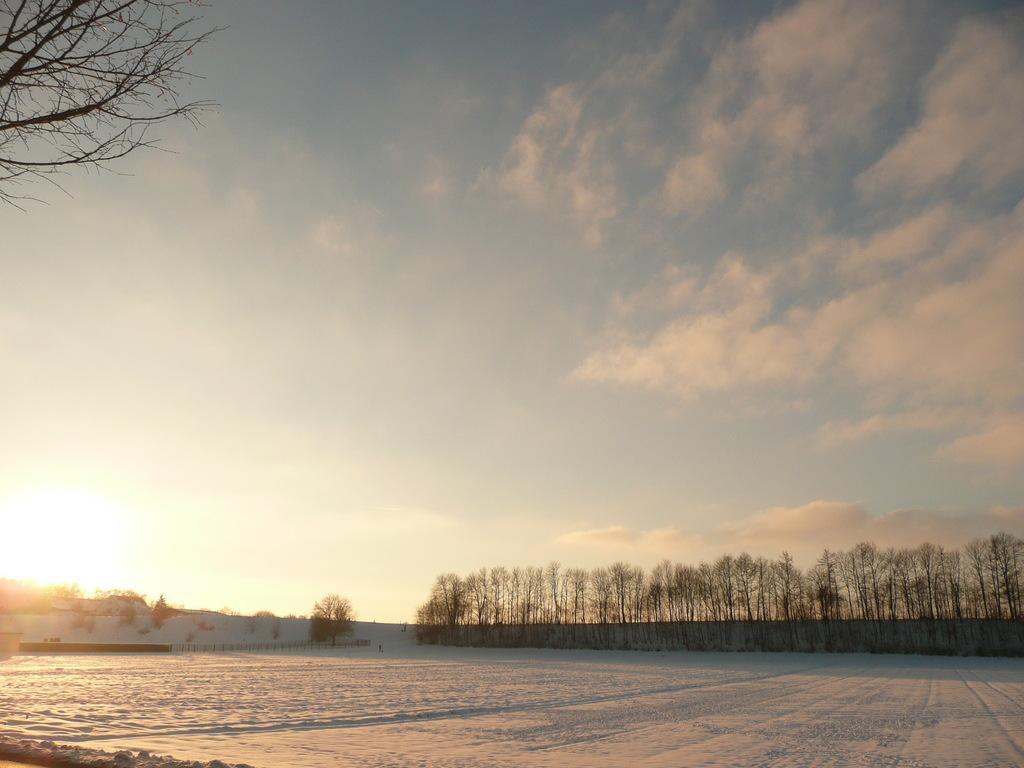How would you summarize this image in a sentence or two? In this image we can see the snow, fencing, trees, and also we can see the clouded sky. 